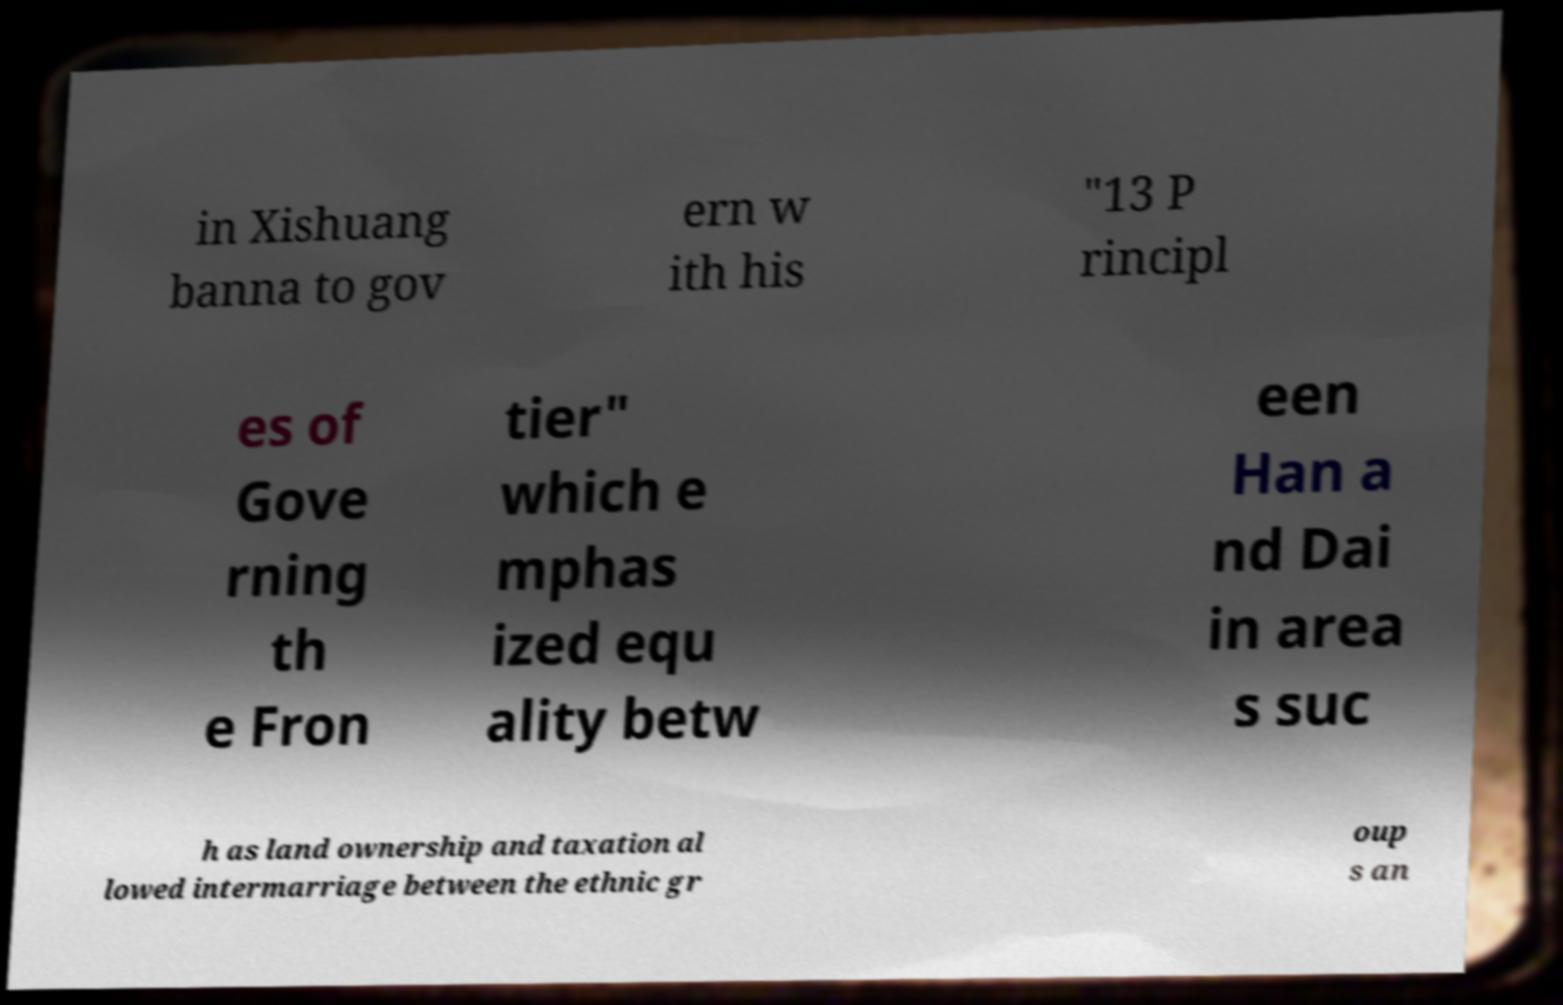I need the written content from this picture converted into text. Can you do that? in Xishuang banna to gov ern w ith his "13 P rincipl es of Gove rning th e Fron tier" which e mphas ized equ ality betw een Han a nd Dai in area s suc h as land ownership and taxation al lowed intermarriage between the ethnic gr oup s an 